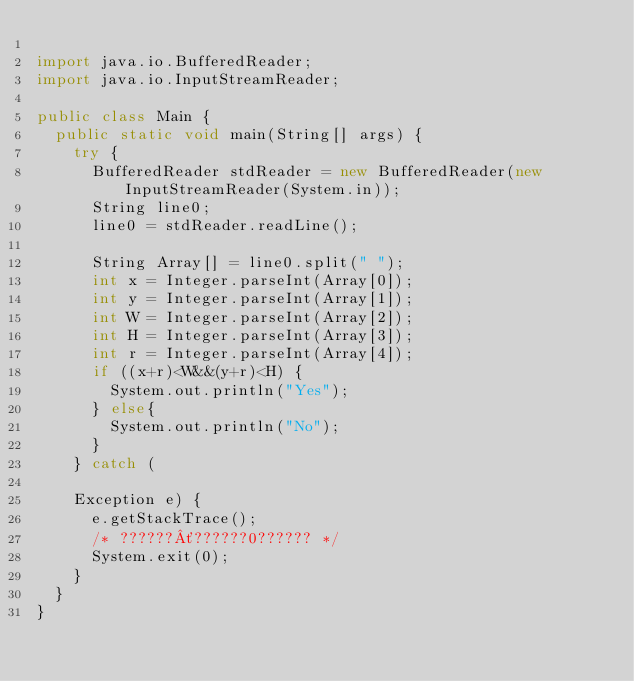Convert code to text. <code><loc_0><loc_0><loc_500><loc_500><_Java_>
import java.io.BufferedReader;
import java.io.InputStreamReader;

public class Main {
	public static void main(String[] args) {
		try {
			BufferedReader stdReader = new BufferedReader(new InputStreamReader(System.in));
			String line0;
			line0 = stdReader.readLine();

			String Array[] = line0.split(" ");
			int x = Integer.parseInt(Array[0]);
			int y = Integer.parseInt(Array[1]);
			int W = Integer.parseInt(Array[2]);
			int H = Integer.parseInt(Array[3]);
			int r = Integer.parseInt(Array[4]);
			if ((x+r)<W&&(y+r)<H) {
				System.out.println("Yes");
			} else{
				System.out.println("No");
			}
		} catch (

		Exception e) {
			e.getStackTrace();
			/* ??????´??????0?????? */
			System.exit(0);
		}
	}
}</code> 